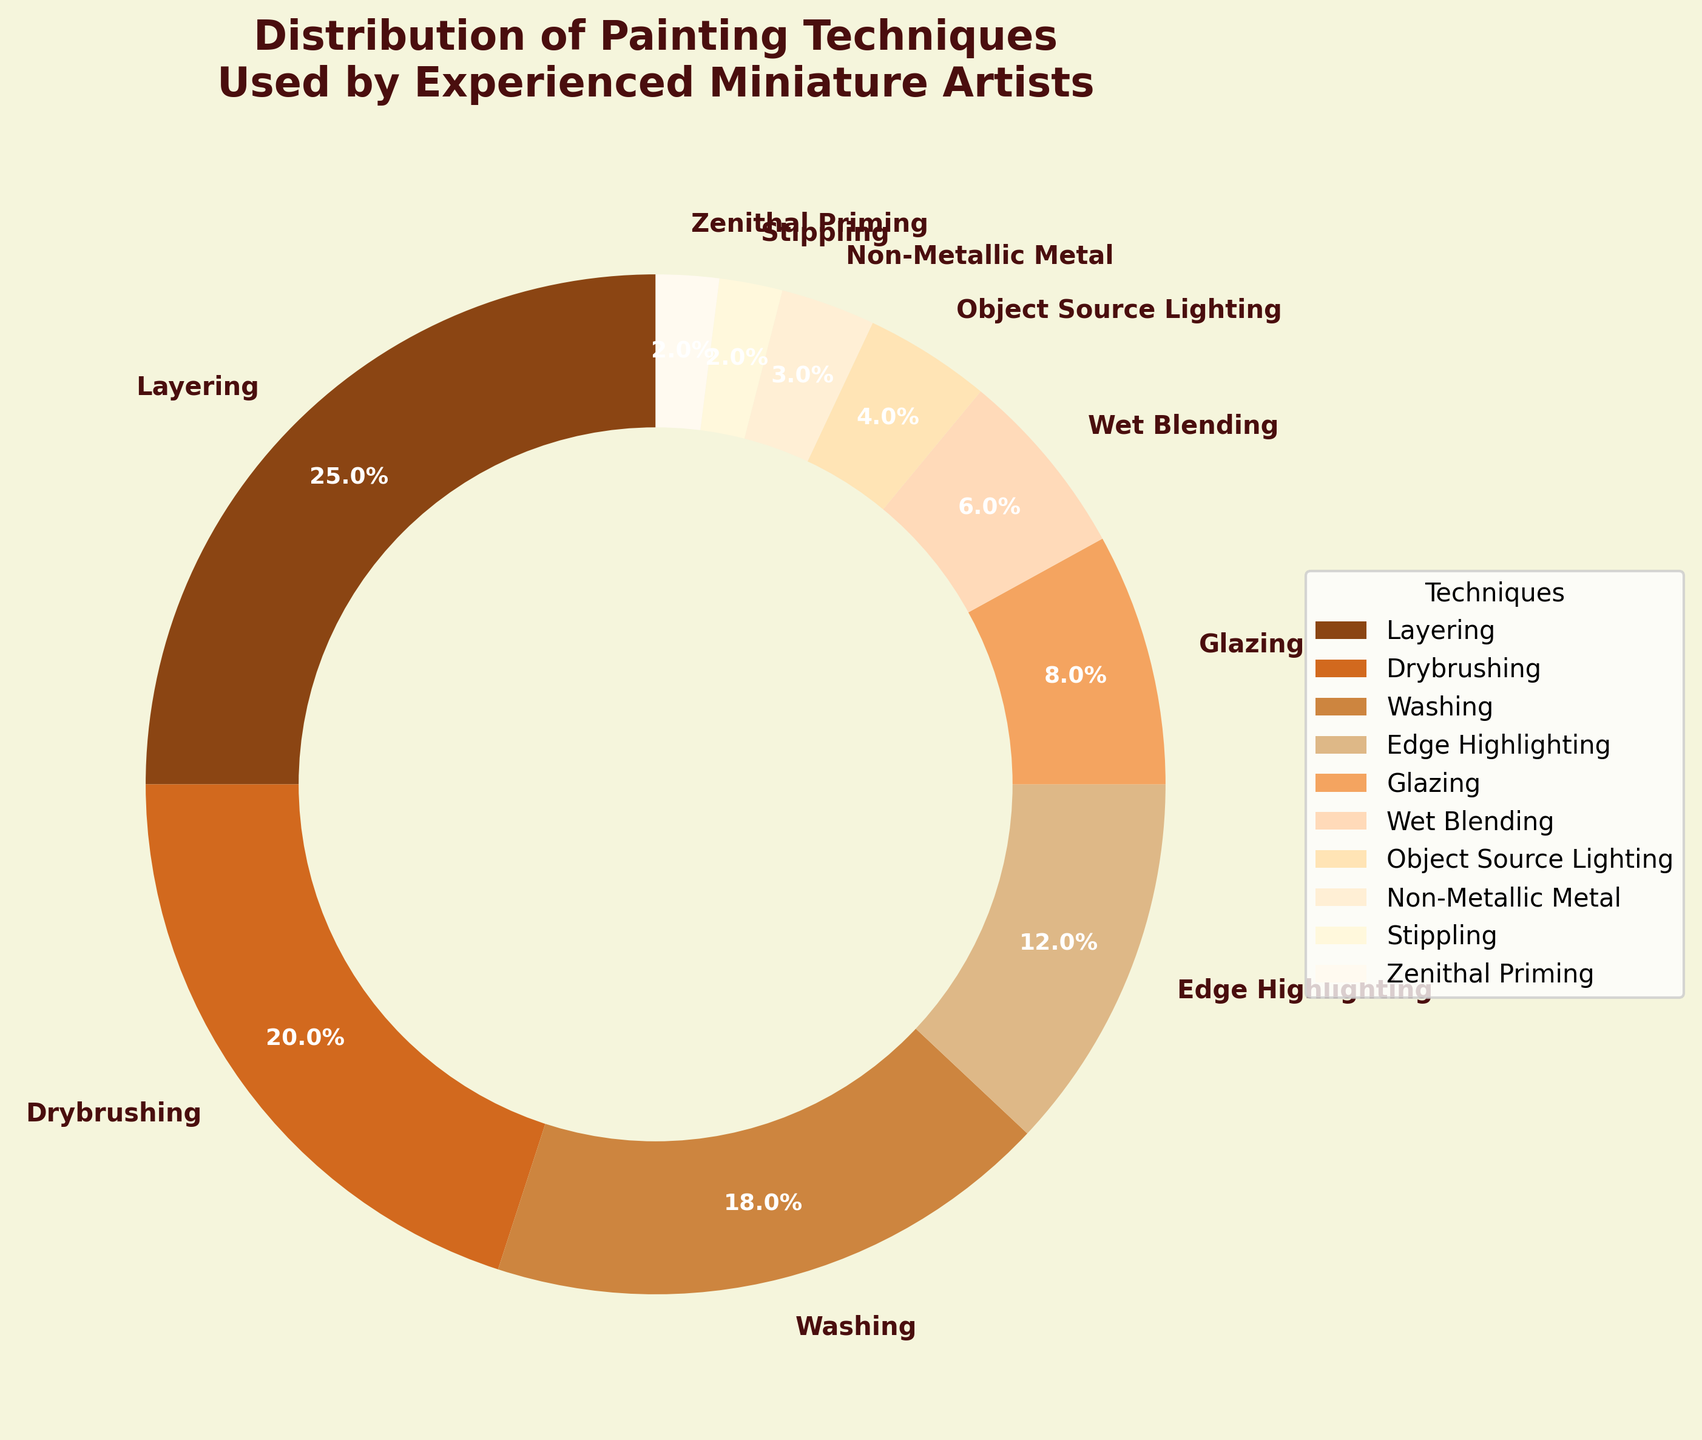What's the most commonly used painting technique according to the pie chart? The pie chart shows the distribution of techniques, and the technique with the largest slice represents the most common technique. Layering has the largest percentage slice at 25%.
Answer: Layering Which two techniques are used by a total of 30% of the artists? We need to find two techniques whose percentages add up to 30%. Drybrushing (20%) and Zenithal Priming (2%) together are 22%. Layering (25%) and Glazing (8%) add up to 33%. Drybrushing (20%) and Washing (18%) add up to 38%. Finally, Drybrushing (20%) and Glazing (8%) add up to 28%. Layering (25%) and Wet Blending (6%) are 31%. The only viable pair is Layering (25%) and Zenithal Priming (2%), but that is just 27%, which is quite close.
Answer: None Between Wet Blending and Glazing, which technique is more prevalent? Compare the sizes of the slices for Wet Blending and Glazing in the pie chart. Glazing has 8%, and Wet Blending has 6%, so Glazing is more prevalent.
Answer: Glazing By what percentage is Edge Highlighting more popular than Non-Metallic Metal? Edge Highlighting shows 12% while Non-Metallic Metal shows 3% in the chart. The difference between these two is calculated as 12% - 3% = 9%.
Answer: 9% Looking at the pie chart colors, which technique is represented by the lightest shade? From the pie chart, the lightest shade color part corresponds to the technique. The lightest shade is associated with the smallest slice, which is Zenithal Priming (2%).
Answer: Zenithal Priming What percentage of artists use techniques that are neither Layering nor Drybrushing? The percentage of artists using Layering is 25% and Drybrushing is 20%. To find the percentage of artists using other techniques, subtract these from 100%: 100% - 25% - 20% = 55%.
Answer: 55% How many techniques are used by less than 10% of the artists each? Count the slices with percentages less than 10%. These techniques are Glazing (8%), Wet Blending (6%), Object Source Lighting (4%), Non-Metallic Metal (3%), Stippling (2%), and Zenithal Priming (2%). In total, there are 6 such techniques.
Answer: 6 